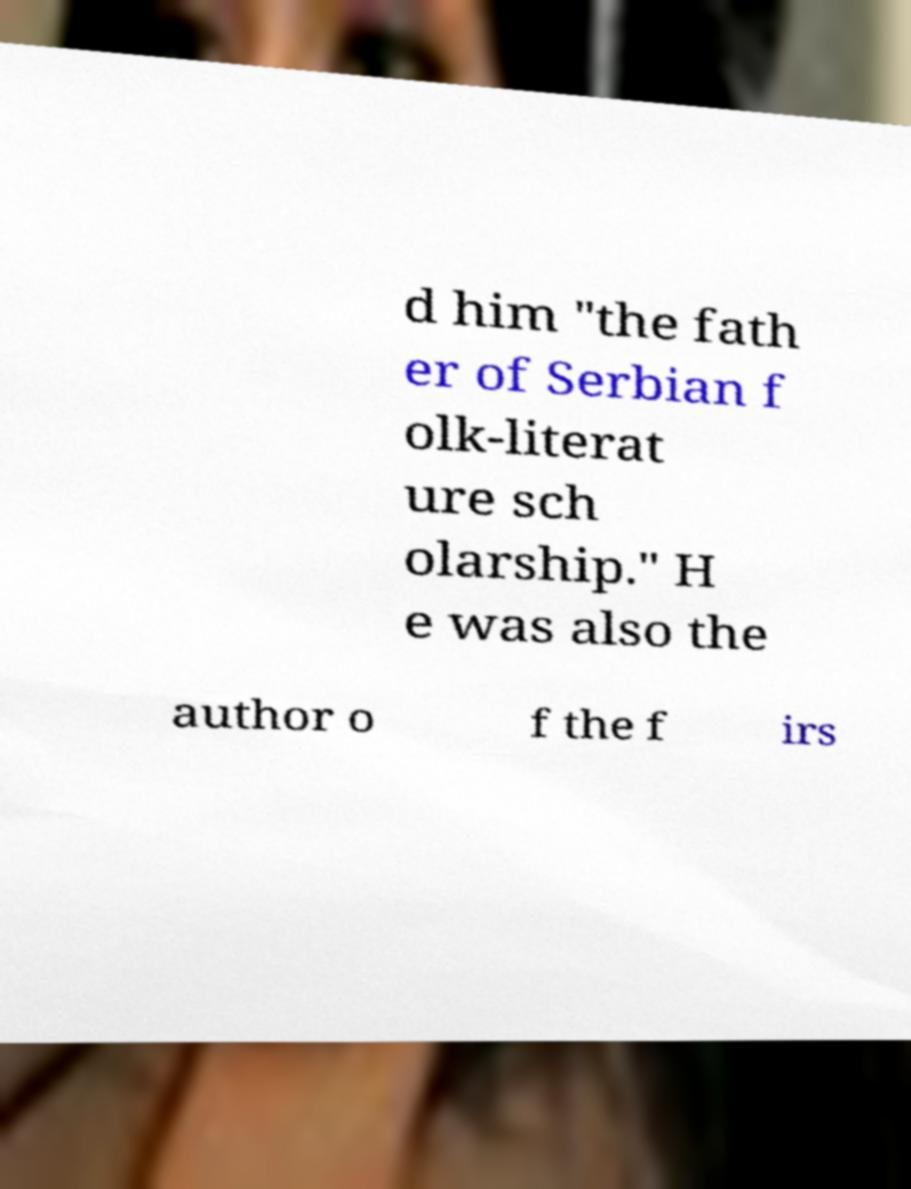Can you accurately transcribe the text from the provided image for me? d him "the fath er of Serbian f olk-literat ure sch olarship." H e was also the author o f the f irs 